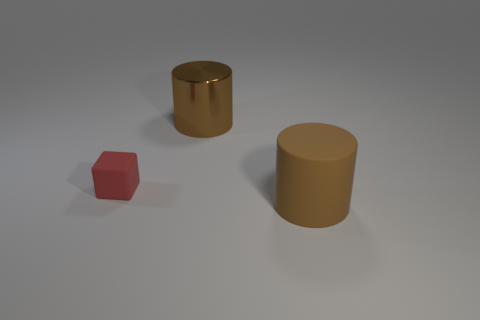Add 3 big brown things. How many objects exist? 6 Subtract all cylinders. How many objects are left? 1 Add 2 small red matte blocks. How many small red matte blocks are left? 3 Add 3 large brown shiny things. How many large brown shiny things exist? 4 Subtract 0 gray cylinders. How many objects are left? 3 Subtract all large brown rubber cylinders. Subtract all brown cylinders. How many objects are left? 0 